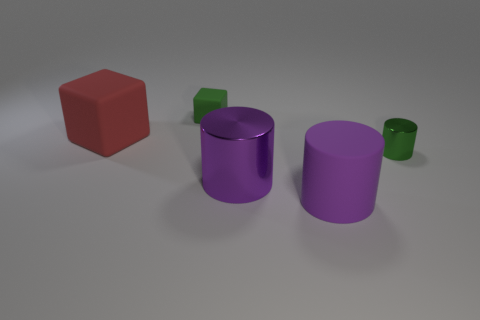Add 1 small cyan shiny cylinders. How many objects exist? 6 Subtract all cylinders. How many objects are left? 2 Subtract all large cubes. Subtract all green rubber cubes. How many objects are left? 3 Add 4 large cylinders. How many large cylinders are left? 6 Add 1 small green metallic cylinders. How many small green metallic cylinders exist? 2 Subtract 0 yellow spheres. How many objects are left? 5 